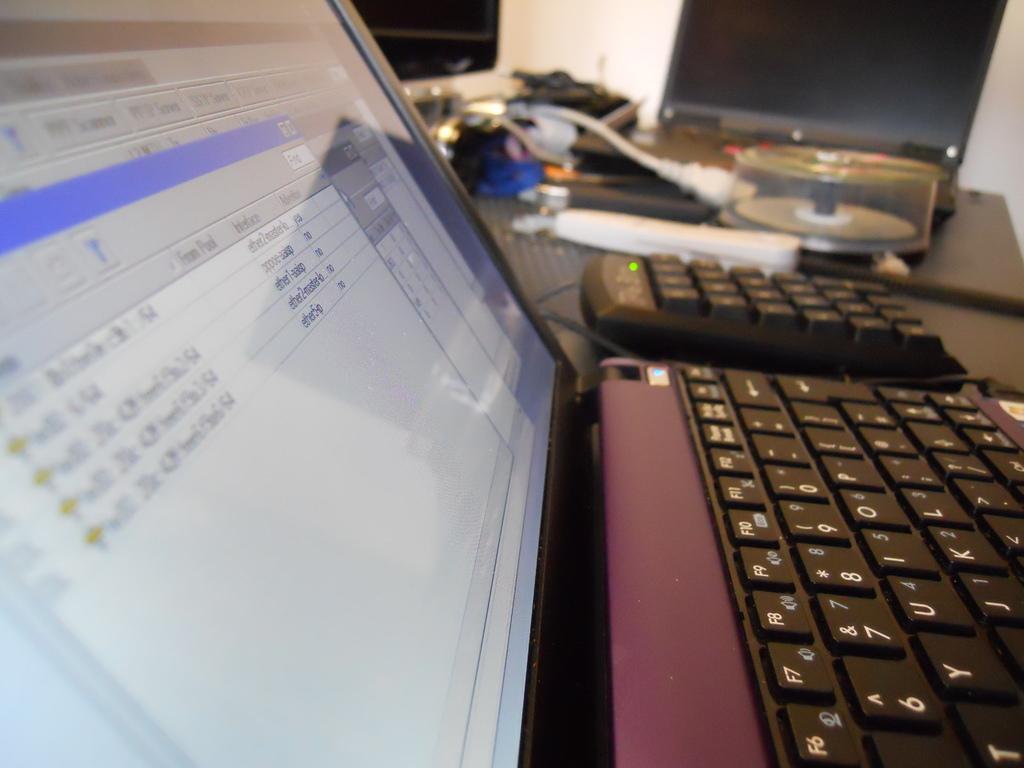In one or two sentences, can you explain what this image depicts? We can see a laptop's,keyboard,CD disk box,cables,monitor and other objects on a platform. In the background we can see the wall. 